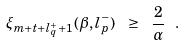<formula> <loc_0><loc_0><loc_500><loc_500>\xi _ { m + t + l ^ { + } _ { q } + 1 } ( \beta , l ^ { - } _ { p } ) \ \geq \ \frac { 2 } { \alpha } \ .</formula> 